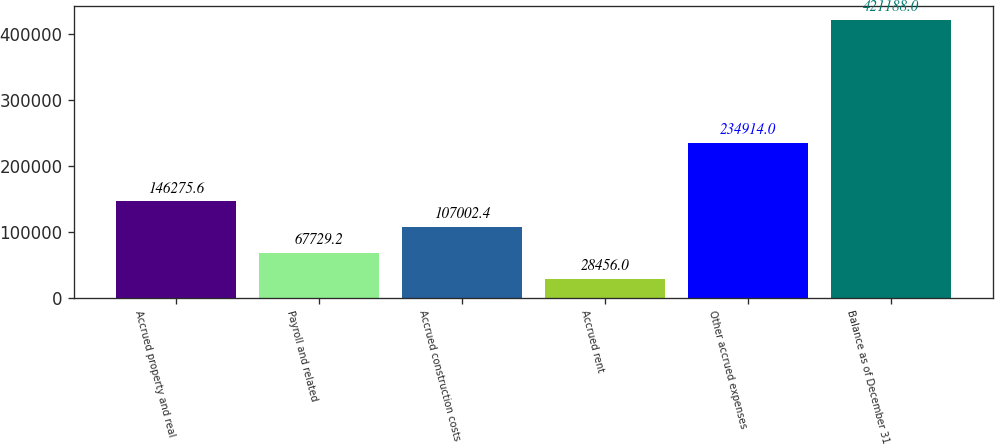Convert chart. <chart><loc_0><loc_0><loc_500><loc_500><bar_chart><fcel>Accrued property and real<fcel>Payroll and related<fcel>Accrued construction costs<fcel>Accrued rent<fcel>Other accrued expenses<fcel>Balance as of December 31<nl><fcel>146276<fcel>67729.2<fcel>107002<fcel>28456<fcel>234914<fcel>421188<nl></chart> 